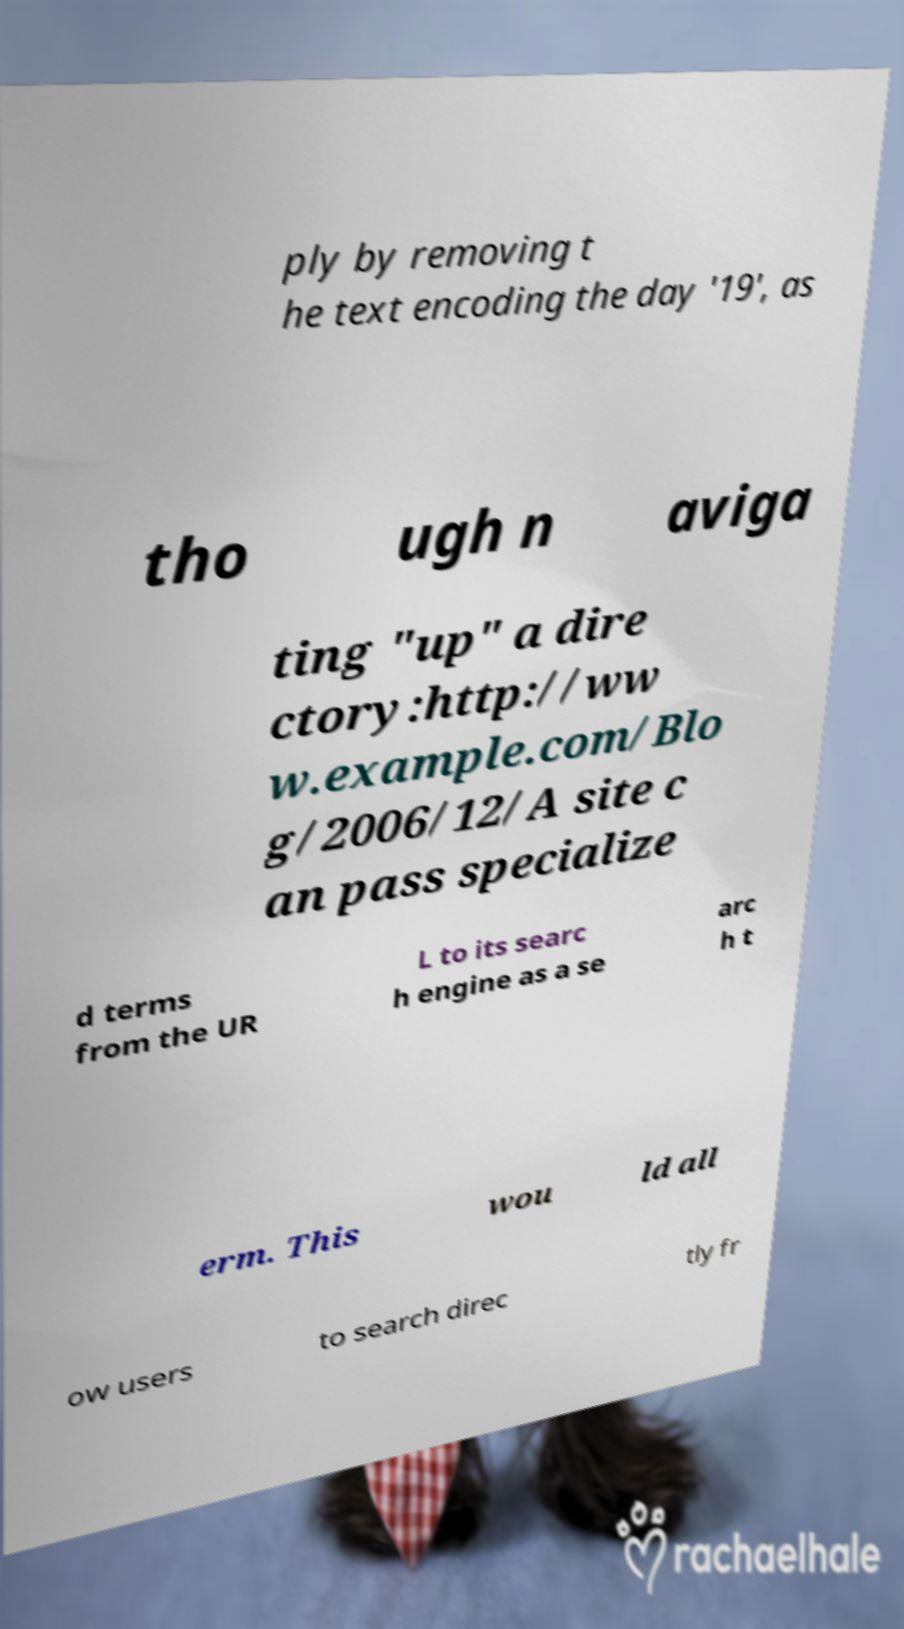There's text embedded in this image that I need extracted. Can you transcribe it verbatim? ply by removing t he text encoding the day '19', as tho ugh n aviga ting "up" a dire ctory:http://ww w.example.com/Blo g/2006/12/A site c an pass specialize d terms from the UR L to its searc h engine as a se arc h t erm. This wou ld all ow users to search direc tly fr 